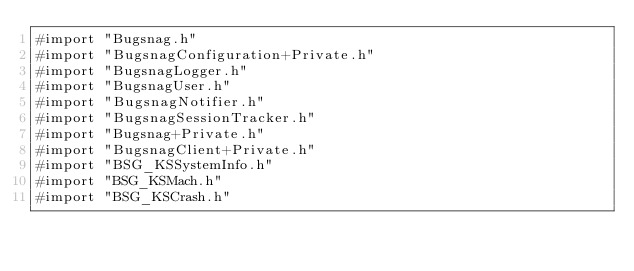<code> <loc_0><loc_0><loc_500><loc_500><_ObjectiveC_>#import "Bugsnag.h"
#import "BugsnagConfiguration+Private.h"
#import "BugsnagLogger.h"
#import "BugsnagUser.h"
#import "BugsnagNotifier.h"
#import "BugsnagSessionTracker.h"
#import "Bugsnag+Private.h"
#import "BugsnagClient+Private.h"
#import "BSG_KSSystemInfo.h"
#import "BSG_KSMach.h"
#import "BSG_KSCrash.h"</code> 